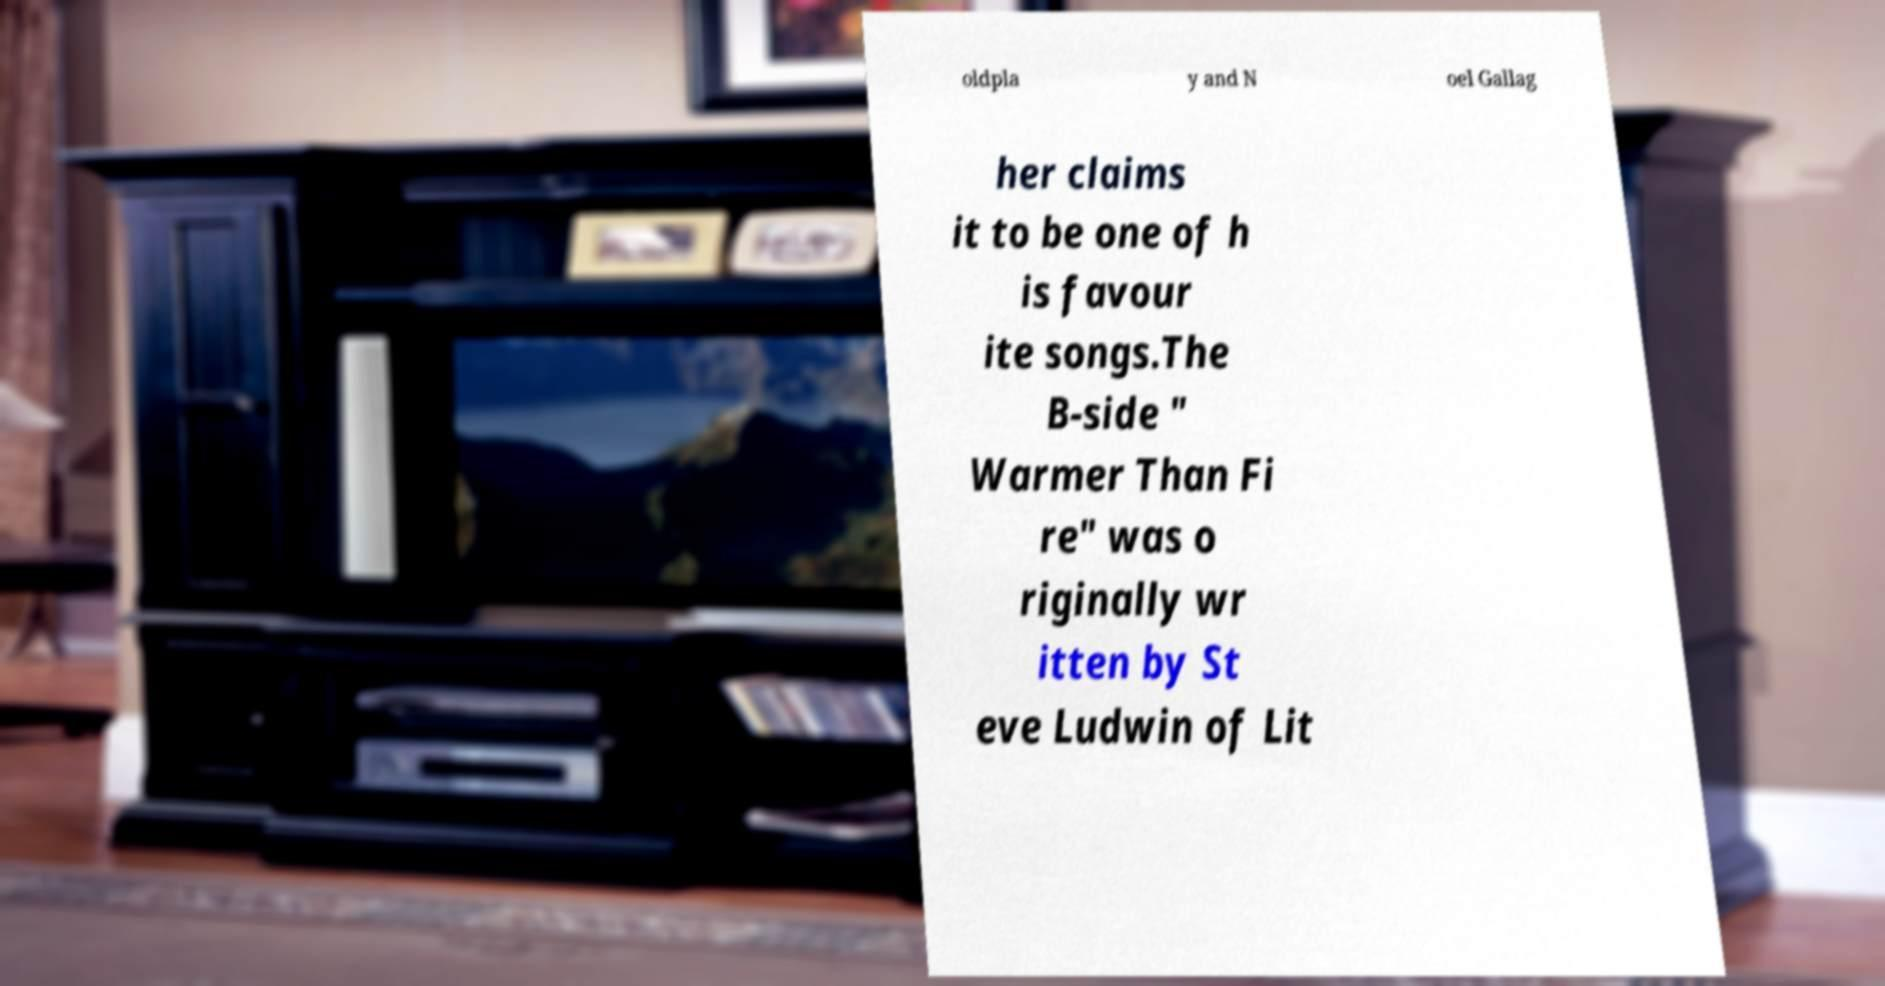Can you accurately transcribe the text from the provided image for me? oldpla y and N oel Gallag her claims it to be one of h is favour ite songs.The B-side " Warmer Than Fi re" was o riginally wr itten by St eve Ludwin of Lit 